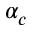Convert formula to latex. <formula><loc_0><loc_0><loc_500><loc_500>\alpha _ { c }</formula> 